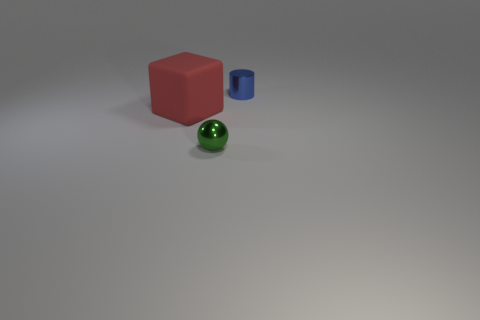Are there any other things that are made of the same material as the big red block?
Your answer should be compact. No. What color is the metal object that is to the right of the thing in front of the rubber object?
Offer a terse response. Blue. How big is the thing that is on the right side of the small thing in front of the object that is right of the tiny green shiny object?
Keep it short and to the point. Small. Do the cube and the thing that is to the right of the tiny green ball have the same material?
Give a very brief answer. No. There is a sphere that is the same material as the cylinder; what size is it?
Ensure brevity in your answer.  Small. Are there any tiny cyan rubber objects that have the same shape as the green shiny object?
Ensure brevity in your answer.  No. What number of things are tiny objects in front of the tiny cylinder or red rubber blocks?
Keep it short and to the point. 2. There is a block that is in front of the small blue metallic cylinder; is it the same color as the thing that is behind the large red block?
Your response must be concise. No. The red rubber thing is what size?
Your answer should be compact. Large. How many large things are either matte objects or green spheres?
Your answer should be very brief. 1. 